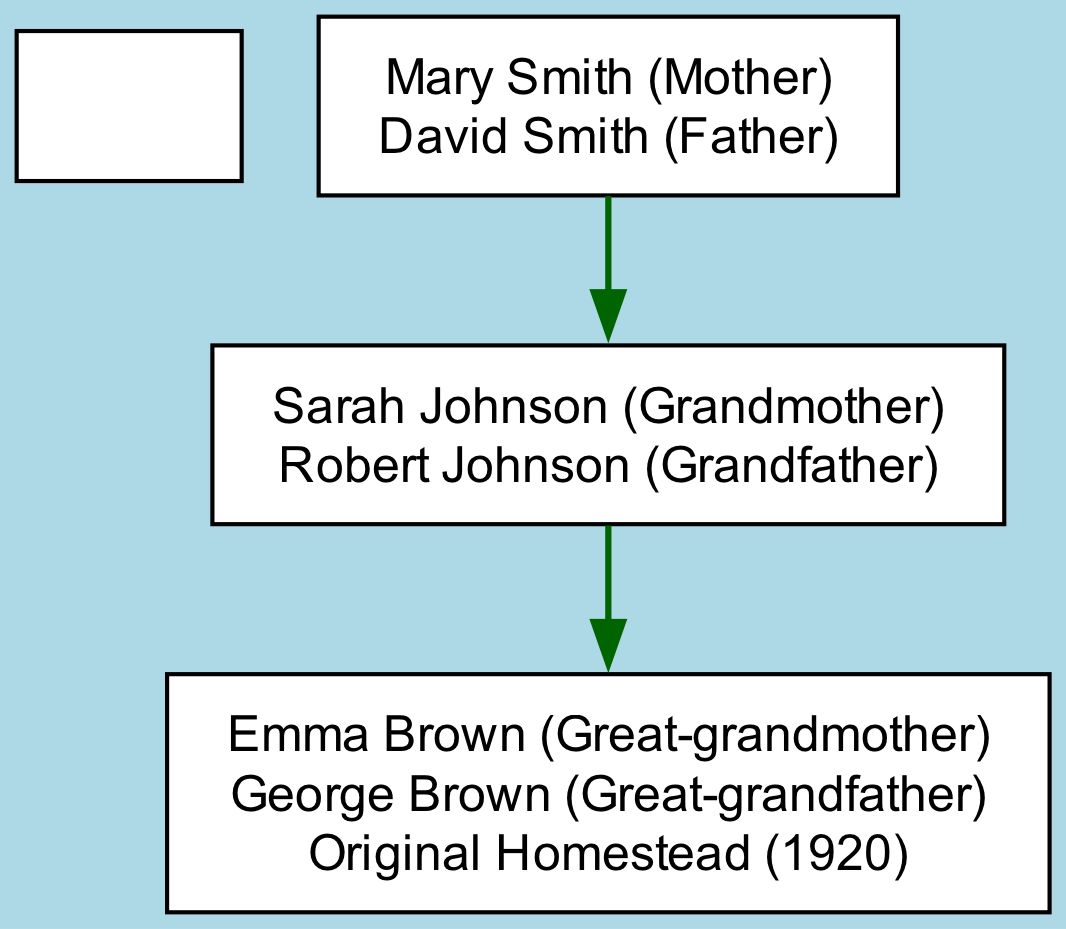What is the name of the client? The diagram identifies "John Smith" as the root individual, labeled as "Client."
Answer: John Smith Who are the parents of the client? The diagram shows that "Mary Smith" and "David Smith" are listed as the client's parents, under the client node.
Answer: Mary Smith and David Smith How many generations are represented in the diagram? The diagram includes three generations: John Smith (client), Mary and David Smith (parents), Sarah and Robert Johnson (grandparents), and Emma and George Brown (great-grandparents), which counts as three generations in total.
Answer: Three What is the name of the great-grandfather? Examining the diagram reveals that the name associated with the great-grandfather is "George Brown," who is labeled as the spouse of "Emma Brown."
Answer: George Brown Which property is associated with the great-grandparents? The label for the great-grandparents section includes the "Original Homestead (1920)" noted alongside the names Emma and George Brown.
Answer: Original Homestead (1920) What relationship do Sarah Johnson and Robert Johnson have with John Smith? In the diagram, Sarah Johnson is listed as the grandmother and Robert Johnson as her spouse, indicating they are John's grandparents.
Answer: Grandparents Which node has a property listed in the diagram? The diagram displays the property information specifically for the great-grandparents' node, as it is the only one noted to have a property associated with it.
Answer: Emma Brown (George Brown) How many children does Mary Smith have? The diagram shows that Mary Smith has one child, identified as "John Smith" (the client), indicating there are no other children listed.
Answer: One What is the relationship between Emma Brown and John Smith? The diagram indicates that Emma Brown is the great-grandmother of John Smith, as reflected in the generational structure of the family tree.
Answer: Great-grandmother 